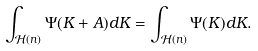<formula> <loc_0><loc_0><loc_500><loc_500>\int _ { \mathcal { H } ( n ) } \Psi ( K + A ) d K = \int _ { \mathcal { H } ( n ) } \Psi ( K ) d K .</formula> 